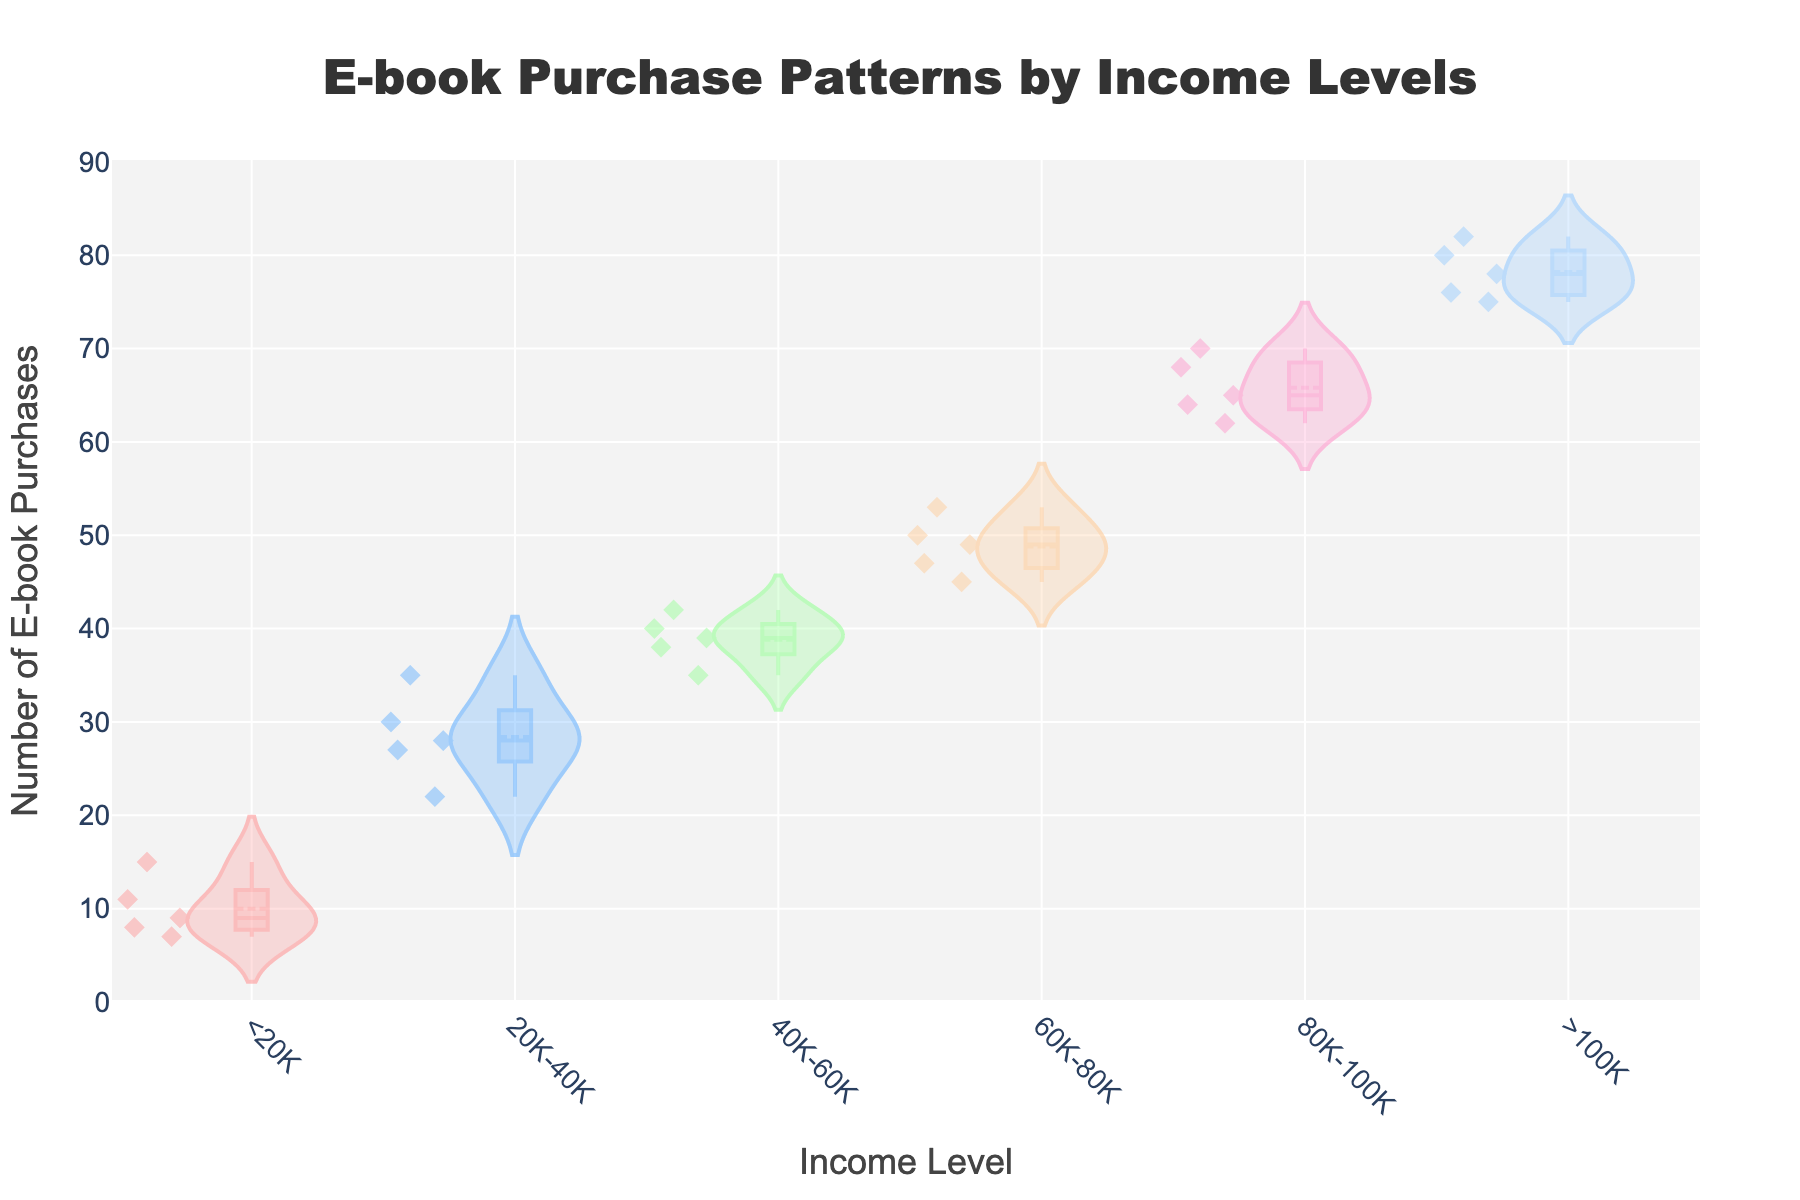What is the title of the figure? The title is typically displayed at the top of the figure, in this case, it is centrally aligned with specific font settings. The title text is "E-book Purchase Patterns by Income Levels".
Answer: E-book Purchase Patterns by Income Levels What does the x-axis of the figure represent? The x-axis title is generally written horizontally below the x-axis, and in this figure, it is specified to be 'Income Level'.
Answer: Income Level Which income level shows the highest number of e-book purchases on average? By observing the mean values indicated by the meanline in the violin plot for each income level, the ">100K" income level has the highest number of e-book purchases.
Answer: >100K Which visual element indicates the distribution spread of e-book purchases for each income level? The width of the violin plots indicates the spread or distribution of e-book purchases for each income level. Wider sections show higher data concentration.
Answer: Width of violin plots What is the range of e-book purchases for the "60K-80K" income level? By looking at the edges of the violin plot for the "60K-80K" income level, we can see that the data points range from 45 to 53 ebook purchases. The box also visually confirms this range.
Answer: 45 to 53 Which income level has the most concentrated set of purchase data points? The concentration of data points is indicated by the width and spread of the violin plot. The "<20K" income level shows a narrower and more concentrated distribution.
Answer: <20K Compare the spread of e-book purchases between "20K-40K" and "40K-60K" income levels. Which one is more spread out? By comparing the widths of the violin plots, the "20K-40K" income level's plot is wider and more varied compared to "40K-60K". Therefore, "20K-40K" has a more spread out distribution.
Answer: 20K-40K How many data points are present for the ">100K" income level? The violin plot includes distinct markers ("diamond" symbols) for each data point. Counting these markers within the ">100K" section reveals there are 5 data points.
Answer: 5 What color represents the "80K-100K" income level in the violin plots? The colors in the plot are arranged sequentially. The "80K-100K" income level is represented by a pinkish color.
Answer: Pinkish Is there a noticeable trend in the number of e-book purchases as the income level increases? Observing the meanlines and distribution patterns of the violin plots, there is a noticeable increase in the average number of e-book purchases as the income levels rise.
Answer: Yes 